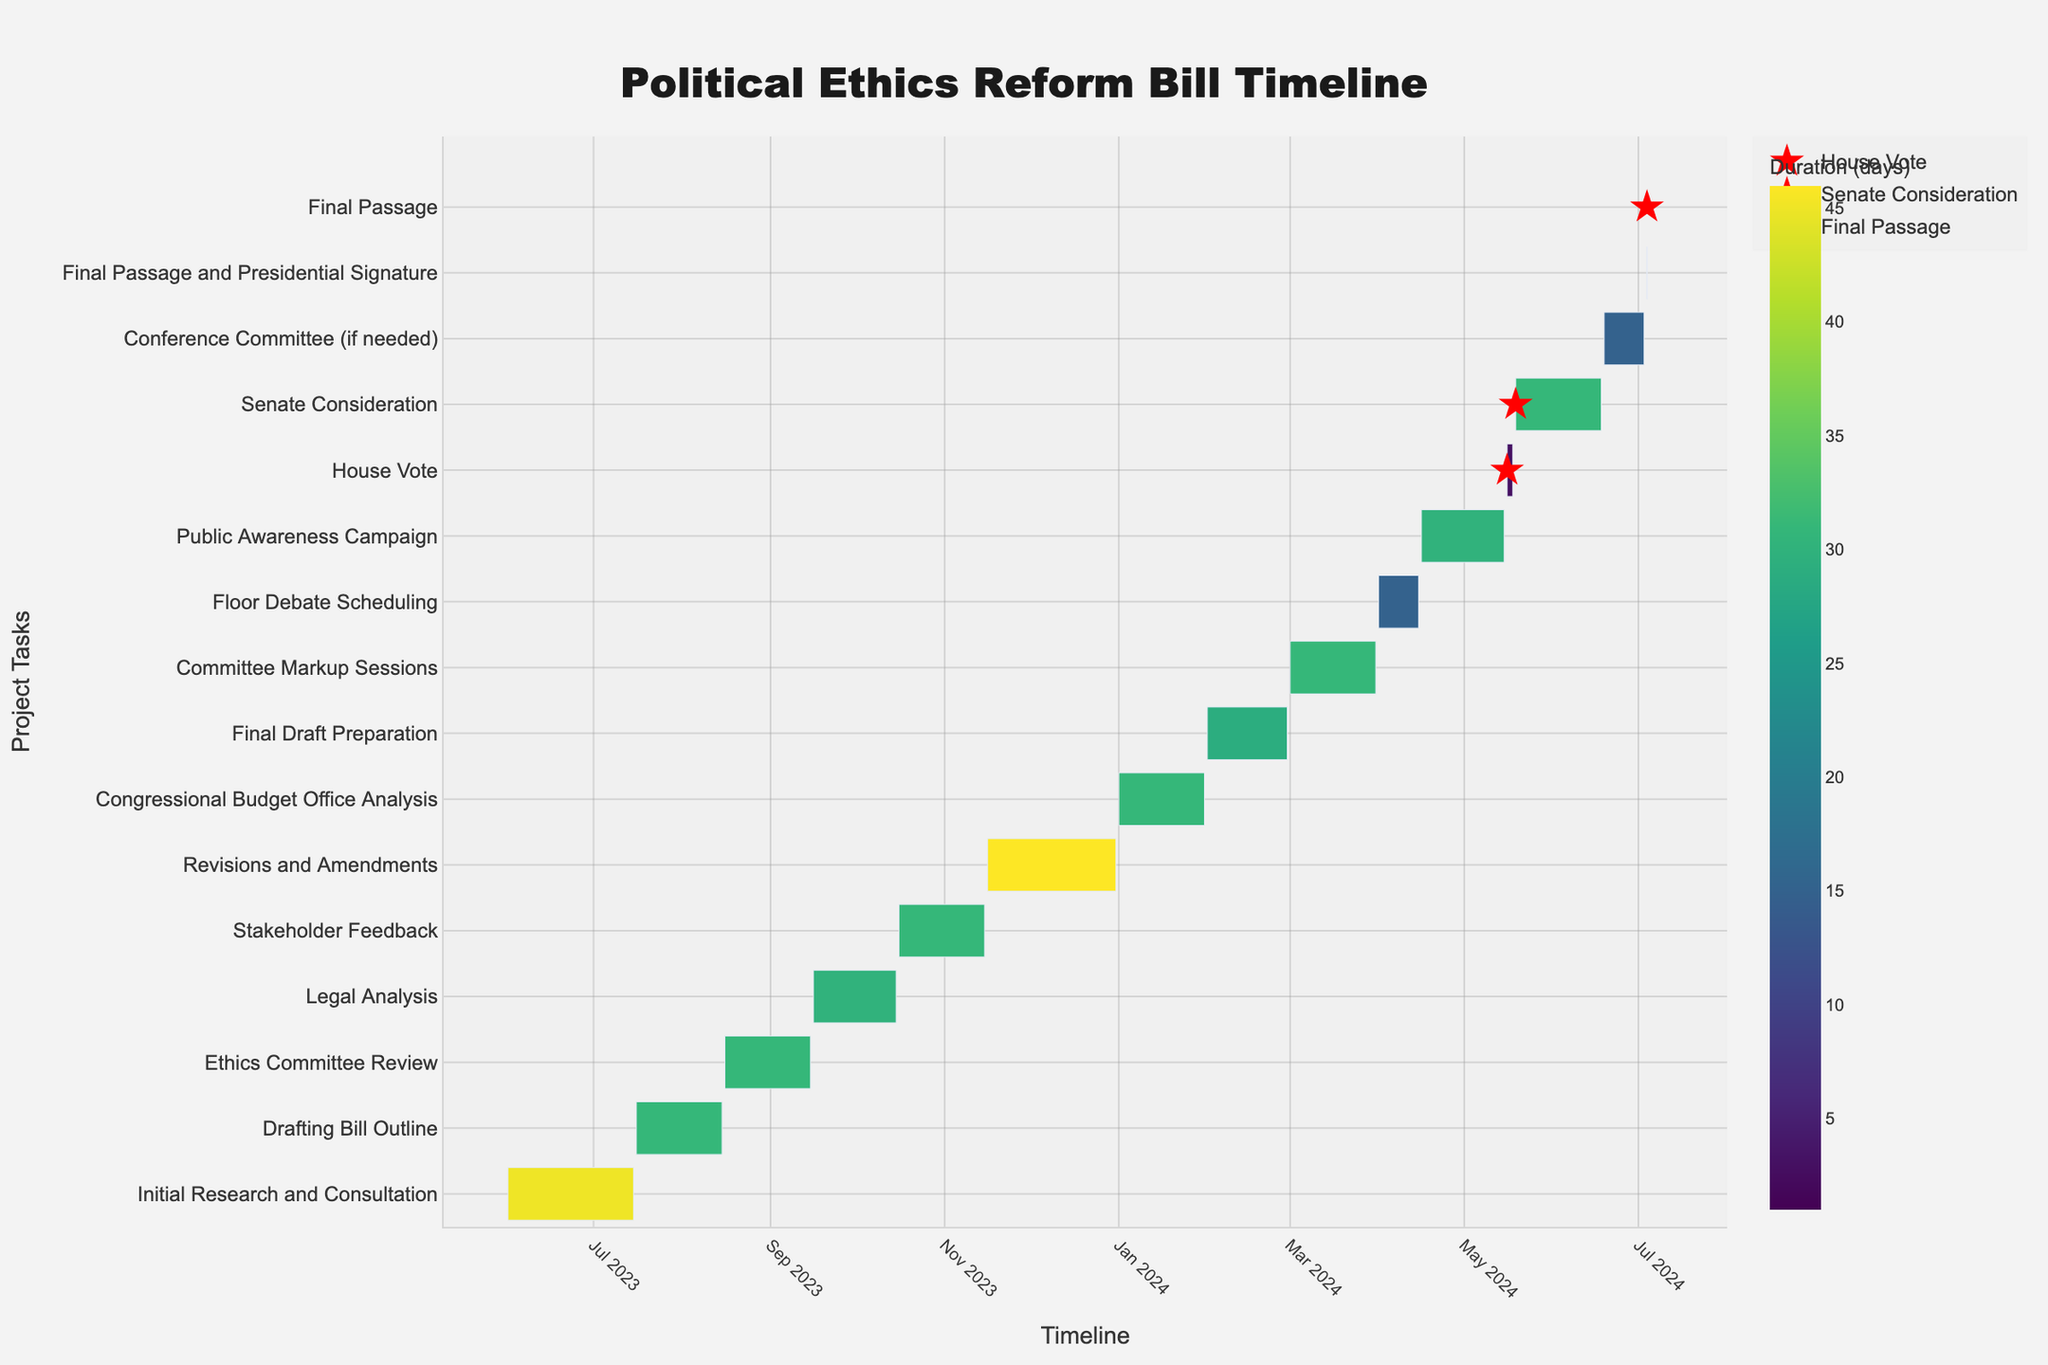what is the title of the figure? The title of the figure is located at the top center of the chart. It provides an overview of what the chart is depicting. In this case, the title reads "Political Ethics Reform Bill Timeline".
Answer: Political Ethics Reform Bill Timeline what date range does the "Drafting Bill Outline" task cover? To find the date range of a task, look at the bars associated with that task on the chart. The "Drafting Bill Outline" task starts on 2023-07-16 and ends on 2023-08-15 as shown by the bar corresponding to this task.
Answer: 2023-07-16 to 2023-08-15 what is the longest task in the timeline? The durations of each task are represented by the length of the bars and are indicated in the "Duration" column. The longest task is the "Revisions and Amendments" which lasts 46 days from 2023-11-16 to 2023-12-31.
Answer: Revisions and Amendments how many tasks have a duration of 30 days? To determine the number of tasks that last exactly 30 days, check the "Duration" column on the chart. The tasks "Legal Analysis" and "Public Awareness Campaign" each have a duration of 30 days.
Answer: 2 which task follows immediately after "Committee Markup Sessions"? To see which task follows another, check the end date of one task and the start date of the following task. "Committee Markup Sessions" ends on 2024-03-31, and "Floor Debate Scheduling" begins on 2024-04-01, indicating it follows immediately after.
Answer: Floor Debate Scheduling how does the duration of the "Initial Research and Consultation" compare to the "Congressional Budget Office Analysis"? To compare durations, look at the "Duration" column. "Initial Research and Consultation" has a duration of 45 days, which is longer than "Congressional Budget Office Analysis" which lasts 31 days.
Answer: "Initial Research and Consultation" is longer what is the total duration of tasks from "Stakeholder Feedback" to "Committee Markup Sessions"? To get the total duration, sum up the durations of all tasks from "Stakeholder Feedback" to "Committee Markup Sessions": 31 (Stakeholder Feedback) + 46 (Revisions and Amendments) + 31 (Congressional Budget Office Analysis) + 29 (Final Draft Preparation) + 31 (Committee Markup Sessions) = 168 days.
Answer: 168 days when is the "House Vote" scheduled? Milestones on the chart are marked with red stars. To find the "House Vote" milestone, look at the position of the red star labeled "House Vote". It is scheduled on 2024-05-16.
Answer: 2024-05-16 why is the "Final Passage and Presidential Signature" marked differently on the chart? The "Final Passage and Presidential Signature" is marked with a red star to signify its importance as a major milestone in the timeline of the project. It indicates the completion of the bill approval process.
Answer: It's a major milestone 